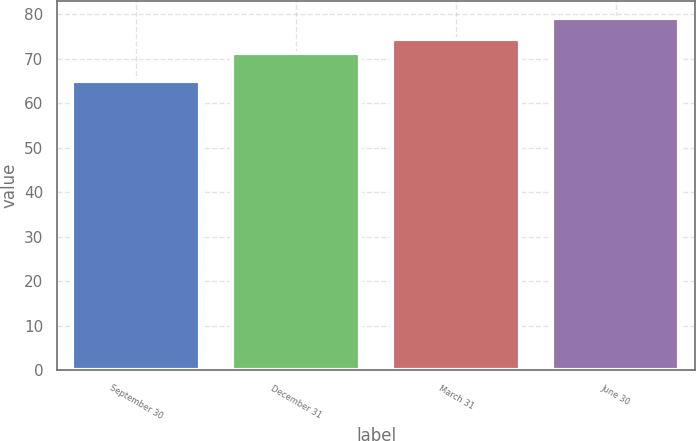<chart> <loc_0><loc_0><loc_500><loc_500><bar_chart><fcel>September 30<fcel>December 31<fcel>March 31<fcel>June 30<nl><fcel>65.02<fcel>71.3<fcel>74.46<fcel>79.1<nl></chart> 